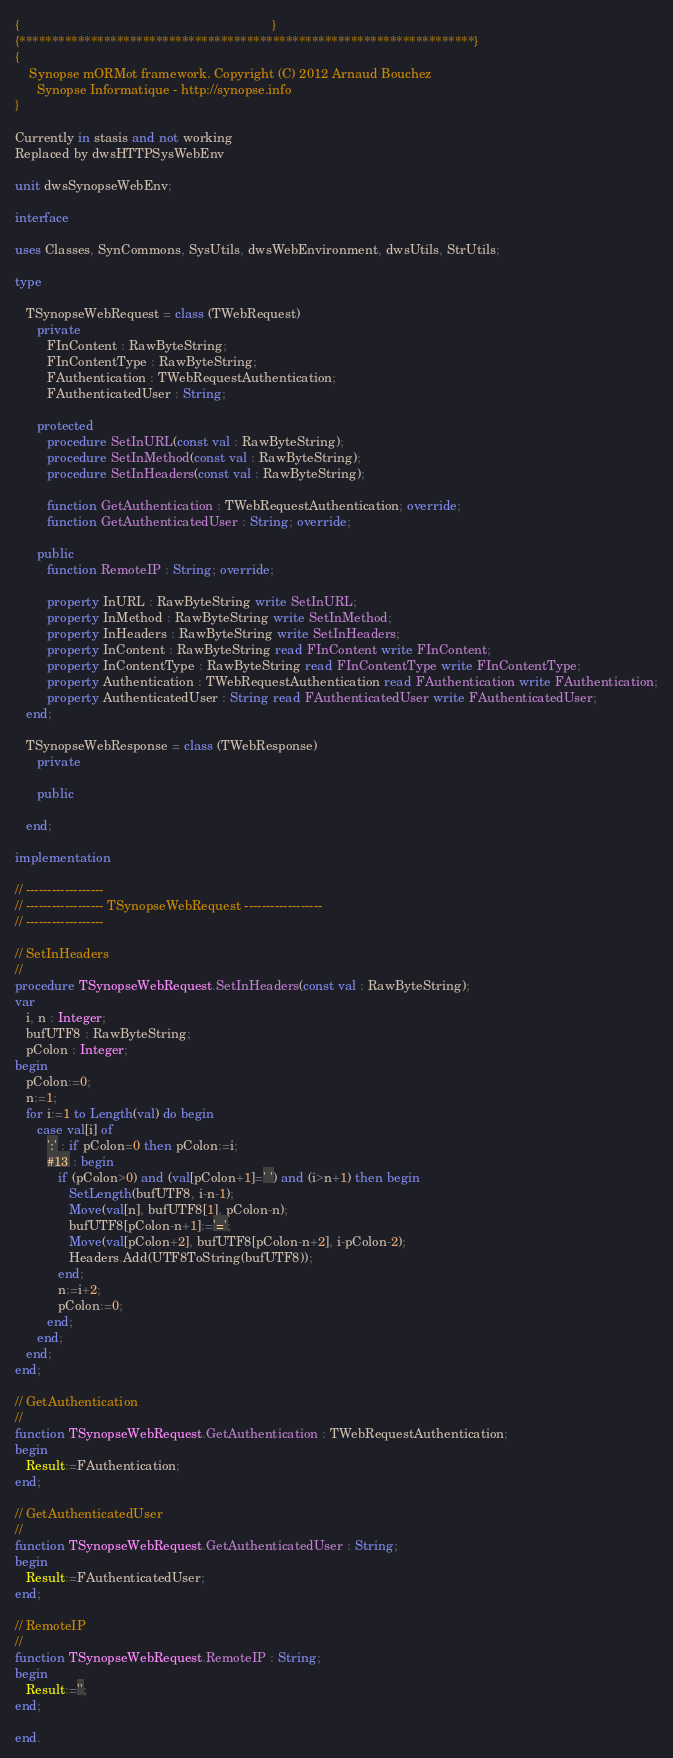<code> <loc_0><loc_0><loc_500><loc_500><_Pascal_>{                                                                      }
{**********************************************************************}
{
    Synopse mORMot framework. Copyright (C) 2012 Arnaud Bouchez
      Synopse Informatique - http://synopse.info
}

Currently in stasis and not working
Replaced by dwsHTTPSysWebEnv

unit dwsSynopseWebEnv;

interface

uses Classes, SynCommons, SysUtils, dwsWebEnvironment, dwsUtils, StrUtils;

type

   TSynopseWebRequest = class (TWebRequest)
      private
         FInContent : RawByteString;
         FInContentType : RawByteString;
         FAuthentication : TWebRequestAuthentication;
         FAuthenticatedUser : String;

      protected
         procedure SetInURL(const val : RawByteString);
         procedure SetInMethod(const val : RawByteString);
         procedure SetInHeaders(const val : RawByteString);

         function GetAuthentication : TWebRequestAuthentication; override;
         function GetAuthenticatedUser : String; override;

      public
         function RemoteIP : String; override;

         property InURL : RawByteString write SetInURL;
         property InMethod : RawByteString write SetInMethod;
         property InHeaders : RawByteString write SetInHeaders;
         property InContent : RawByteString read FInContent write FInContent;
         property InContentType : RawByteString read FInContentType write FInContentType;
         property Authentication : TWebRequestAuthentication read FAuthentication write FAuthentication;
         property AuthenticatedUser : String read FAuthenticatedUser write FAuthenticatedUser;
   end;

   TSynopseWebResponse = class (TWebResponse)
      private

      public

   end;

implementation

// ------------------
// ------------------ TSynopseWebRequest ------------------
// ------------------

// SetInHeaders
//
procedure TSynopseWebRequest.SetInHeaders(const val : RawByteString);
var
   i, n : Integer;
   bufUTF8 : RawByteString;
   pColon : Integer;
begin
   pColon:=0;
   n:=1;
   for i:=1 to Length(val) do begin
      case val[i] of
         ':' : if pColon=0 then pColon:=i;
         #13 : begin
            if (pColon>0) and (val[pColon+1]=' ') and (i>n+1) then begin
               SetLength(bufUTF8, i-n-1);
               Move(val[n], bufUTF8[1], pColon-n);
               bufUTF8[pColon-n+1]:='=';
               Move(val[pColon+2], bufUTF8[pColon-n+2], i-pColon-2);
               Headers.Add(UTF8ToString(bufUTF8));
            end;
            n:=i+2;
            pColon:=0;
         end;
      end;
   end;
end;

// GetAuthentication
//
function TSynopseWebRequest.GetAuthentication : TWebRequestAuthentication;
begin
   Result:=FAuthentication;
end;

// GetAuthenticatedUser
//
function TSynopseWebRequest.GetAuthenticatedUser : String;
begin
   Result:=FAuthenticatedUser;
end;

// RemoteIP
//
function TSynopseWebRequest.RemoteIP : String;
begin
   Result:='';
end;

end.
</code> 